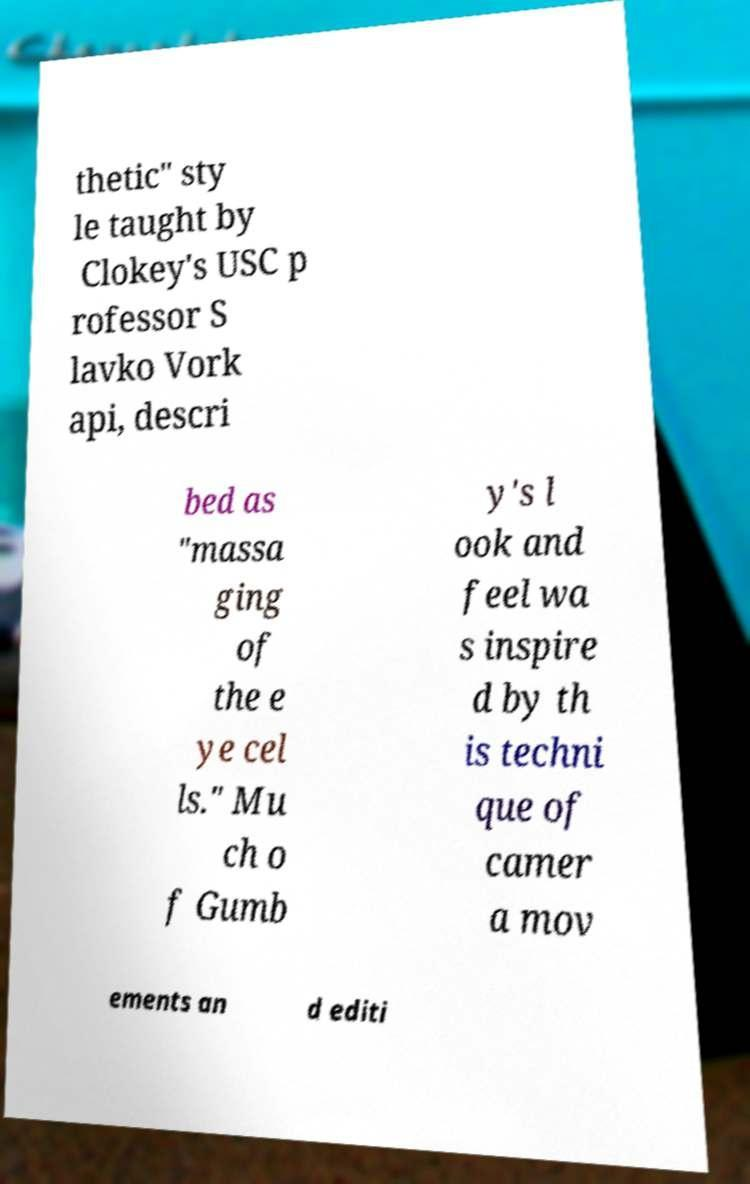Can you accurately transcribe the text from the provided image for me? thetic" sty le taught by Clokey's USC p rofessor S lavko Vork api, descri bed as "massa ging of the e ye cel ls." Mu ch o f Gumb y's l ook and feel wa s inspire d by th is techni que of camer a mov ements an d editi 